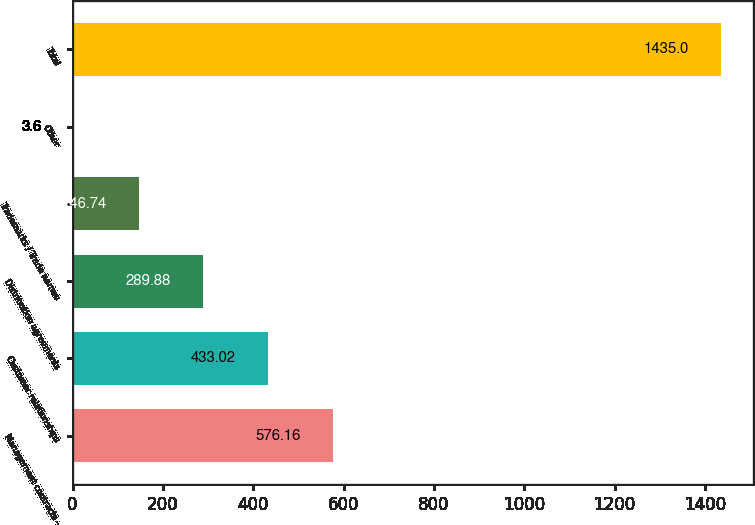<chart> <loc_0><loc_0><loc_500><loc_500><bar_chart><fcel>Management contracts -<fcel>Customer relationships<fcel>Distribution agreements<fcel>Trademarks / Trade names<fcel>Other<fcel>Total<nl><fcel>576.16<fcel>433.02<fcel>289.88<fcel>146.74<fcel>3.6<fcel>1435<nl></chart> 